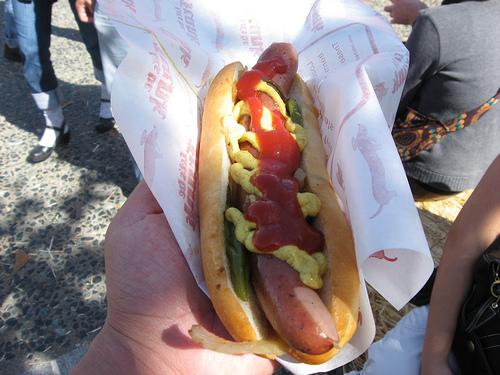What is this sandwich wrapped in?
Be succinct. Paper. Is this a vegan meal?
Give a very brief answer. No. What condiments have been used?
Answer briefly. Mustard and catsup. 